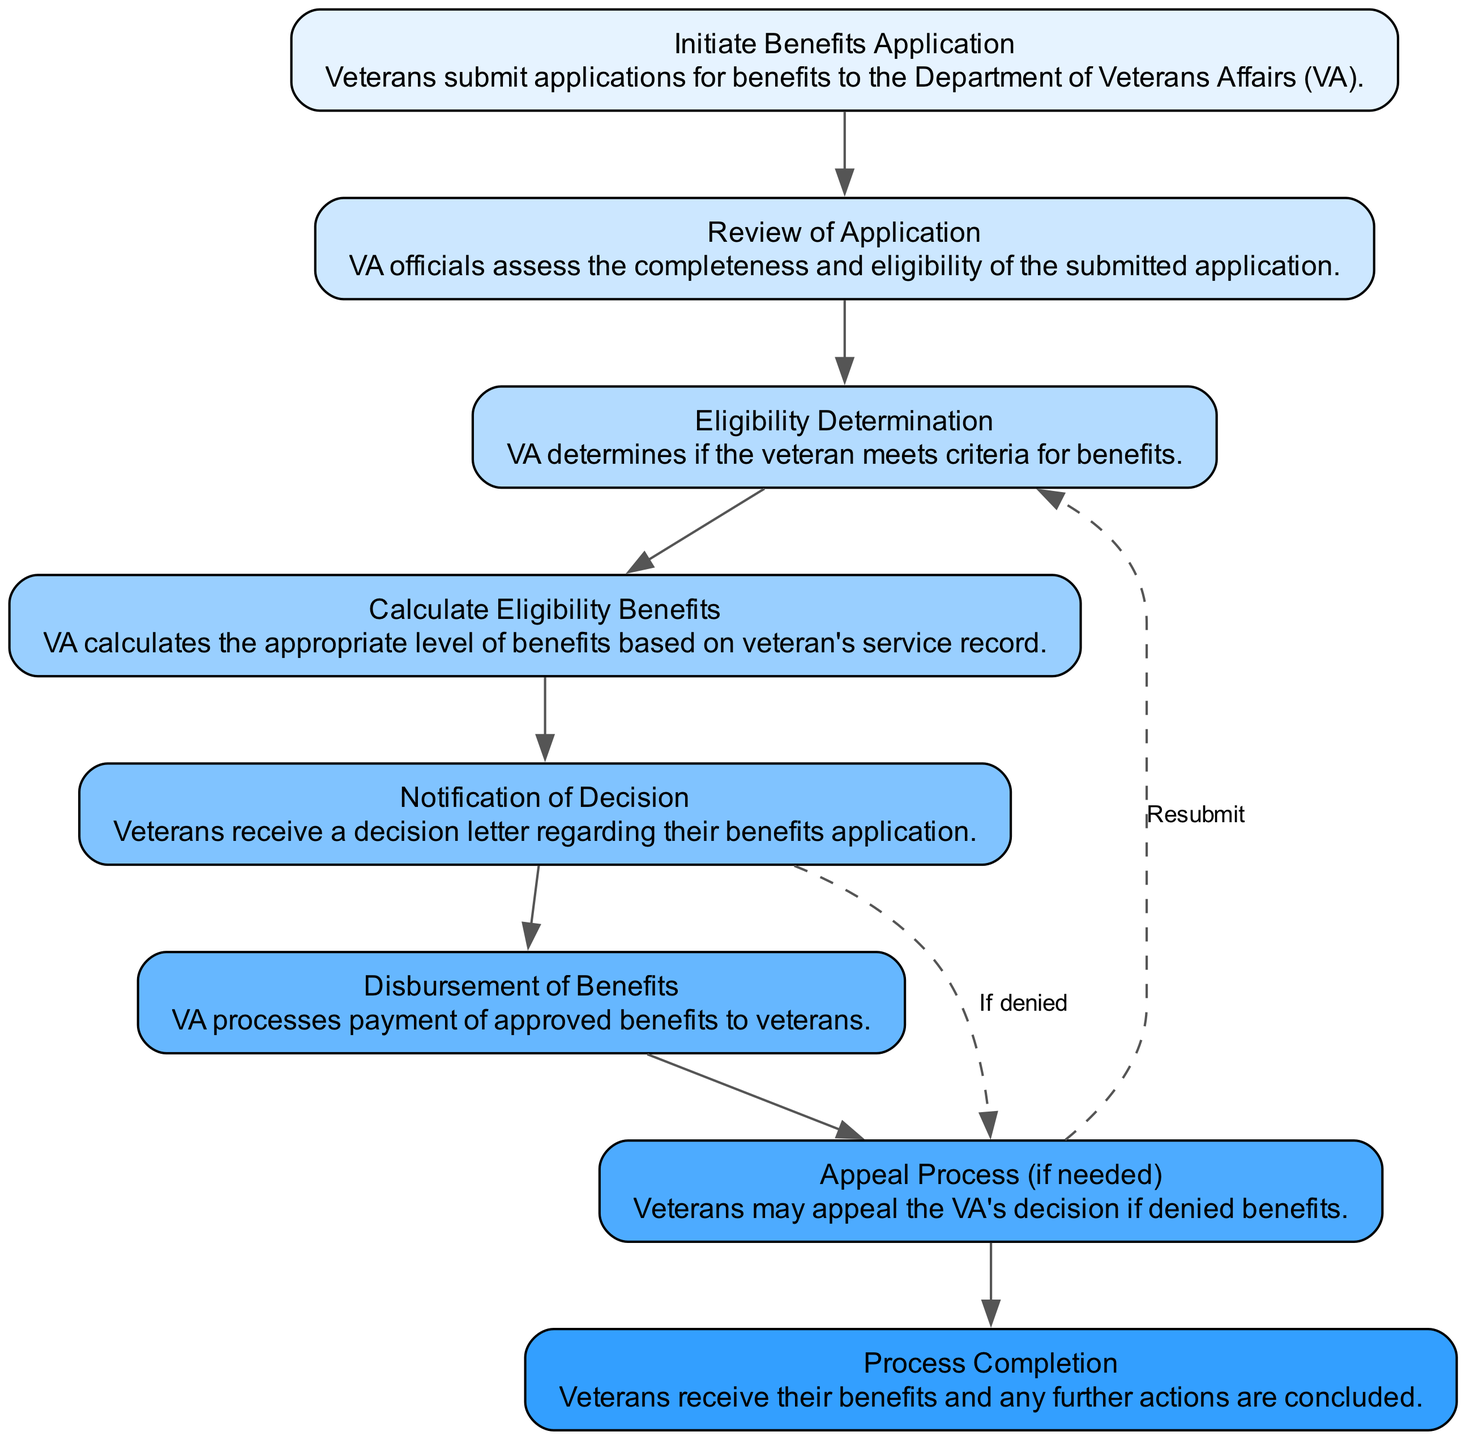What is the first step in the process? The first step in the flow chart is "Initiate Benefits Application," which describes the action of veterans submitting applications for benefits to the VA.
Answer: Initiate Benefits Application How many total steps are in the process? By counting the nodes in the diagram, we identify there are eight distinct steps including the start and end.
Answer: Eight What is the last step in the benefits distribution process? The last step is described as "Process Completion," which indicates that veterans receive their benefits and all further actions are concluded.
Answer: Process Completion What happens if the veterans' application is denied? If the veterans' application is denied, they move to the "Appeal Process," which is indicated by a dashed line leading from "Notification of Decision."
Answer: Appeal Process What does the "Calculate Eligibility Benefits" step involve? This step involves the VA calculating the appropriate level of benefits based on the veteran's service record as stated in the description for that node.
Answer: Calculate Eligibility Benefits Which step does a veteran go back to after the appeal? After the appeal process, if the appeal is submitted, the veteran returns to the "Eligibility Determination" step as indicated by the edge connecting "Appeal Process" to "Eligibility Determination."
Answer: Eligibility Determination How is the flow of the process from "Benefits Calculation" to "Notification of Decision"? The flow from "Benefits Calculation" to "Notification of Decision" is direct; once the benefits are calculated, a decision letter is issued to the veteran immediately afterward.
Answer: Direct What is indicated by the dashed line from "Decision Notification"? The dashed line indicates that an appeal can be made if the benefits application is denied, which adds a conditional aspect to the process.
Answer: Appeal process if denied What is the role of VA in the "Application Review" step? In the "Application Review" step, VA officials assess the completeness and eligibility of the submitted application, which is key to the entire process.
Answer: Assess completeness and eligibility 